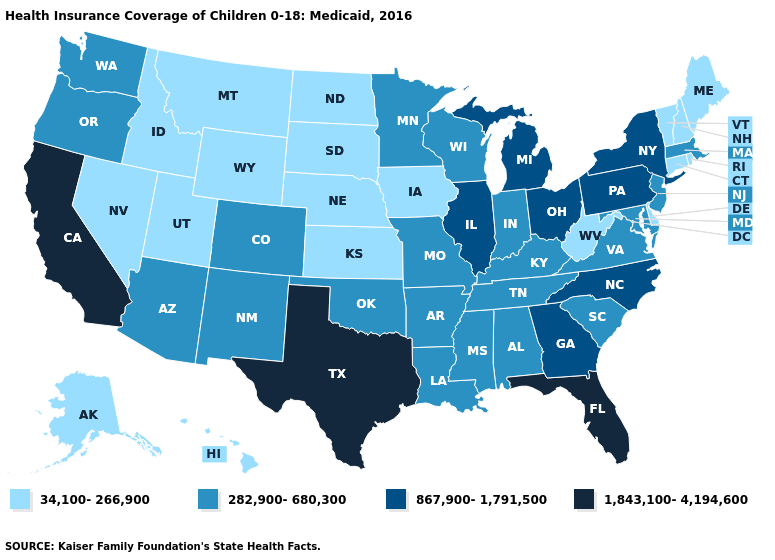What is the value of Oregon?
Quick response, please. 282,900-680,300. Name the states that have a value in the range 282,900-680,300?
Answer briefly. Alabama, Arizona, Arkansas, Colorado, Indiana, Kentucky, Louisiana, Maryland, Massachusetts, Minnesota, Mississippi, Missouri, New Jersey, New Mexico, Oklahoma, Oregon, South Carolina, Tennessee, Virginia, Washington, Wisconsin. Does Nevada have the same value as Georgia?
Write a very short answer. No. Name the states that have a value in the range 34,100-266,900?
Quick response, please. Alaska, Connecticut, Delaware, Hawaii, Idaho, Iowa, Kansas, Maine, Montana, Nebraska, Nevada, New Hampshire, North Dakota, Rhode Island, South Dakota, Utah, Vermont, West Virginia, Wyoming. What is the value of Idaho?
Concise answer only. 34,100-266,900. Name the states that have a value in the range 867,900-1,791,500?
Concise answer only. Georgia, Illinois, Michigan, New York, North Carolina, Ohio, Pennsylvania. Does North Dakota have the highest value in the MidWest?
Be succinct. No. Does the map have missing data?
Give a very brief answer. No. Does Oklahoma have a higher value than New Jersey?
Short answer required. No. What is the highest value in states that border New York?
Give a very brief answer. 867,900-1,791,500. Name the states that have a value in the range 1,843,100-4,194,600?
Concise answer only. California, Florida, Texas. Name the states that have a value in the range 34,100-266,900?
Keep it brief. Alaska, Connecticut, Delaware, Hawaii, Idaho, Iowa, Kansas, Maine, Montana, Nebraska, Nevada, New Hampshire, North Dakota, Rhode Island, South Dakota, Utah, Vermont, West Virginia, Wyoming. Among the states that border Minnesota , which have the lowest value?
Be succinct. Iowa, North Dakota, South Dakota. What is the lowest value in the USA?
Short answer required. 34,100-266,900. 